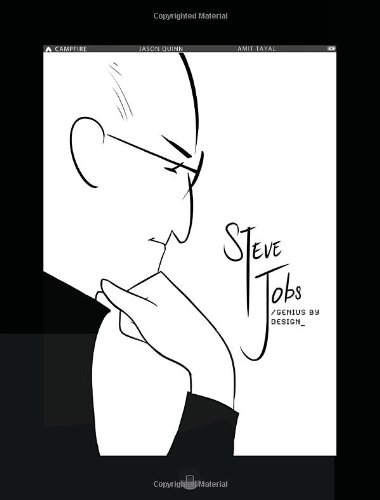Is this a kids book? Yes, it's classified under children's books, specifically designed as a graphic novel to captivate and educate young readers about historical figures. 